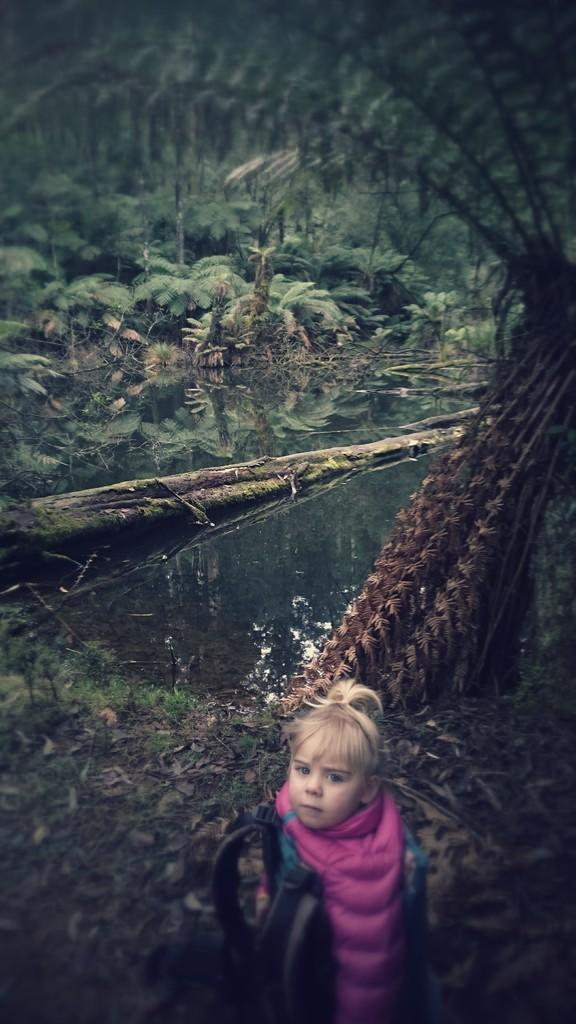Who is the main subject in the image? There is a girl in the image. What is the girl wearing? The girl is wearing a dress. What type of natural elements can be seen in the image? There are plants, trees, water, and land visible in the image. What type of orange is being used to create harmony in the image? There is no orange or reference to harmony in the image; it features a girl wearing a dress and natural elements like plants, trees, water, and land. 